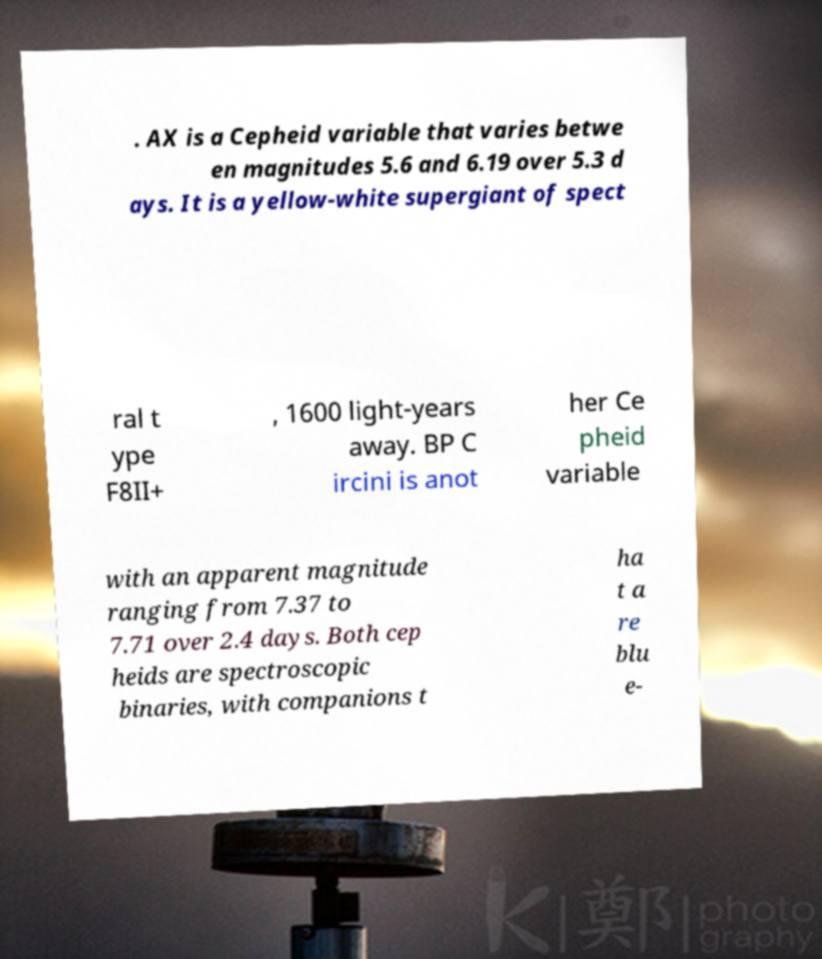Can you accurately transcribe the text from the provided image for me? . AX is a Cepheid variable that varies betwe en magnitudes 5.6 and 6.19 over 5.3 d ays. It is a yellow-white supergiant of spect ral t ype F8II+ , 1600 light-years away. BP C ircini is anot her Ce pheid variable with an apparent magnitude ranging from 7.37 to 7.71 over 2.4 days. Both cep heids are spectroscopic binaries, with companions t ha t a re blu e- 